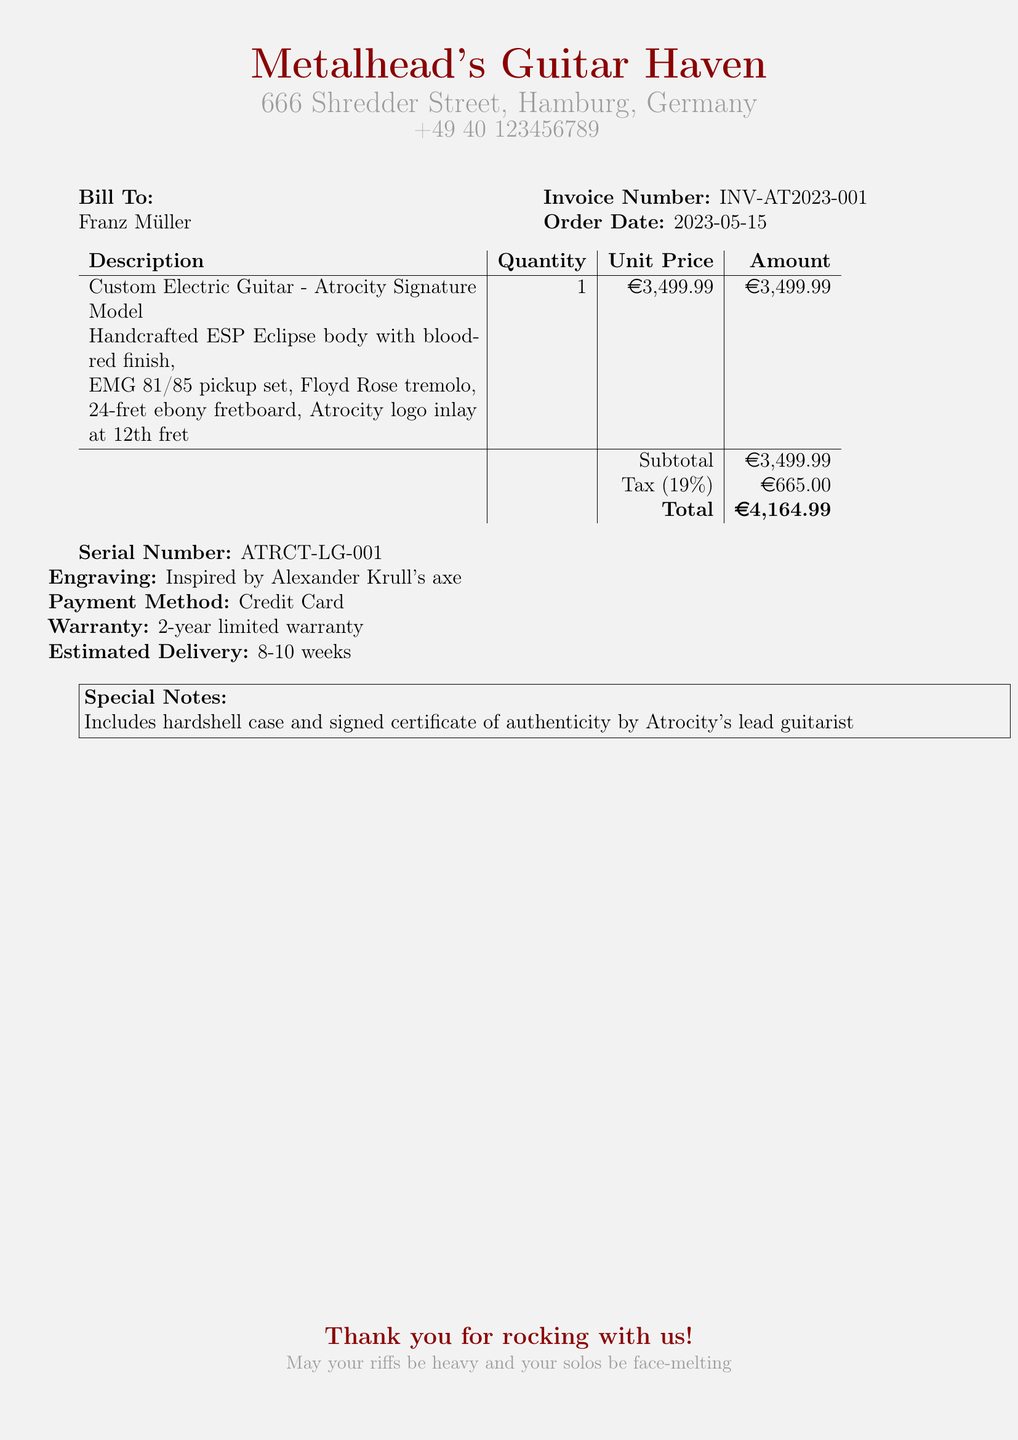What is the name of the music equipment store? The store's name is presented prominently at the top of the document.
Answer: Metalhead's Guitar Haven What is the invoice number? The invoice number is listed in the section detailing customer and order information.
Answer: INV-AT2023-001 What is the total amount due? The total amount is displayed in the summary table as the final tally.
Answer: €4,164.99 Who is the bill addressed to? The name of the individual receiving the invoice is specified at the top of the document.
Answer: Franz Müller What is the estimated delivery time? The estimated delivery time is mentioned towards the end of the document.
Answer: 8-10 weeks What is the warranty period for the guitar? The warranty information is clearly stated in the document.
Answer: 2-year limited warranty What type of guitar is being purchased? The specific model is detailed in the product description section.
Answer: Atrocity Signature Model What engraving is included on the guitar? The engraving information is given below the product details in the document.
Answer: Inspired by Alexander Krull's axe What is included with the purchase? The special notes section outlines additional items that come with the purchase.
Answer: Hardshell case and signed certificate of authenticity by Atrocity's lead guitarist 